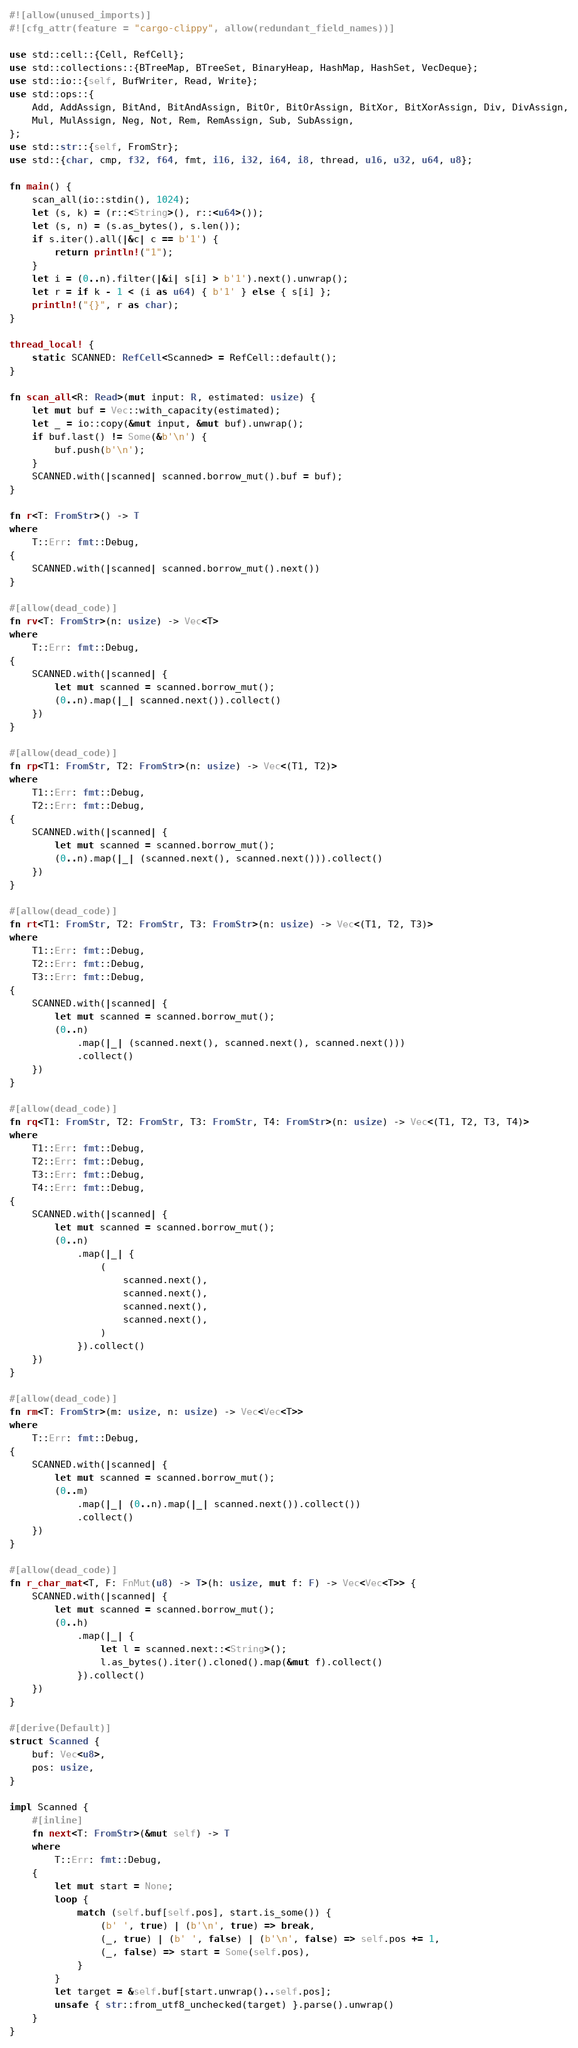<code> <loc_0><loc_0><loc_500><loc_500><_Rust_>#![allow(unused_imports)]
#![cfg_attr(feature = "cargo-clippy", allow(redundant_field_names))]

use std::cell::{Cell, RefCell};
use std::collections::{BTreeMap, BTreeSet, BinaryHeap, HashMap, HashSet, VecDeque};
use std::io::{self, BufWriter, Read, Write};
use std::ops::{
    Add, AddAssign, BitAnd, BitAndAssign, BitOr, BitOrAssign, BitXor, BitXorAssign, Div, DivAssign,
    Mul, MulAssign, Neg, Not, Rem, RemAssign, Sub, SubAssign,
};
use std::str::{self, FromStr};
use std::{char, cmp, f32, f64, fmt, i16, i32, i64, i8, thread, u16, u32, u64, u8};

fn main() {
    scan_all(io::stdin(), 1024);
    let (s, k) = (r::<String>(), r::<u64>());
    let (s, n) = (s.as_bytes(), s.len());
    if s.iter().all(|&c| c == b'1') {
        return println!("1");
    }
    let i = (0..n).filter(|&i| s[i] > b'1').next().unwrap();
    let r = if k - 1 < (i as u64) { b'1' } else { s[i] };
    println!("{}", r as char);
}

thread_local! {
    static SCANNED: RefCell<Scanned> = RefCell::default();
}

fn scan_all<R: Read>(mut input: R, estimated: usize) {
    let mut buf = Vec::with_capacity(estimated);
    let _ = io::copy(&mut input, &mut buf).unwrap();
    if buf.last() != Some(&b'\n') {
        buf.push(b'\n');
    }
    SCANNED.with(|scanned| scanned.borrow_mut().buf = buf);
}

fn r<T: FromStr>() -> T
where
    T::Err: fmt::Debug,
{
    SCANNED.with(|scanned| scanned.borrow_mut().next())
}

#[allow(dead_code)]
fn rv<T: FromStr>(n: usize) -> Vec<T>
where
    T::Err: fmt::Debug,
{
    SCANNED.with(|scanned| {
        let mut scanned = scanned.borrow_mut();
        (0..n).map(|_| scanned.next()).collect()
    })
}

#[allow(dead_code)]
fn rp<T1: FromStr, T2: FromStr>(n: usize) -> Vec<(T1, T2)>
where
    T1::Err: fmt::Debug,
    T2::Err: fmt::Debug,
{
    SCANNED.with(|scanned| {
        let mut scanned = scanned.borrow_mut();
        (0..n).map(|_| (scanned.next(), scanned.next())).collect()
    })
}

#[allow(dead_code)]
fn rt<T1: FromStr, T2: FromStr, T3: FromStr>(n: usize) -> Vec<(T1, T2, T3)>
where
    T1::Err: fmt::Debug,
    T2::Err: fmt::Debug,
    T3::Err: fmt::Debug,
{
    SCANNED.with(|scanned| {
        let mut scanned = scanned.borrow_mut();
        (0..n)
            .map(|_| (scanned.next(), scanned.next(), scanned.next()))
            .collect()
    })
}

#[allow(dead_code)]
fn rq<T1: FromStr, T2: FromStr, T3: FromStr, T4: FromStr>(n: usize) -> Vec<(T1, T2, T3, T4)>
where
    T1::Err: fmt::Debug,
    T2::Err: fmt::Debug,
    T3::Err: fmt::Debug,
    T4::Err: fmt::Debug,
{
    SCANNED.with(|scanned| {
        let mut scanned = scanned.borrow_mut();
        (0..n)
            .map(|_| {
                (
                    scanned.next(),
                    scanned.next(),
                    scanned.next(),
                    scanned.next(),
                )
            }).collect()
    })
}

#[allow(dead_code)]
fn rm<T: FromStr>(m: usize, n: usize) -> Vec<Vec<T>>
where
    T::Err: fmt::Debug,
{
    SCANNED.with(|scanned| {
        let mut scanned = scanned.borrow_mut();
        (0..m)
            .map(|_| (0..n).map(|_| scanned.next()).collect())
            .collect()
    })
}

#[allow(dead_code)]
fn r_char_mat<T, F: FnMut(u8) -> T>(h: usize, mut f: F) -> Vec<Vec<T>> {
    SCANNED.with(|scanned| {
        let mut scanned = scanned.borrow_mut();
        (0..h)
            .map(|_| {
                let l = scanned.next::<String>();
                l.as_bytes().iter().cloned().map(&mut f).collect()
            }).collect()
    })
}

#[derive(Default)]
struct Scanned {
    buf: Vec<u8>,
    pos: usize,
}

impl Scanned {
    #[inline]
    fn next<T: FromStr>(&mut self) -> T
    where
        T::Err: fmt::Debug,
    {
        let mut start = None;
        loop {
            match (self.buf[self.pos], start.is_some()) {
                (b' ', true) | (b'\n', true) => break,
                (_, true) | (b' ', false) | (b'\n', false) => self.pos += 1,
                (_, false) => start = Some(self.pos),
            }
        }
        let target = &self.buf[start.unwrap()..self.pos];
        unsafe { str::from_utf8_unchecked(target) }.parse().unwrap()
    }
}
</code> 